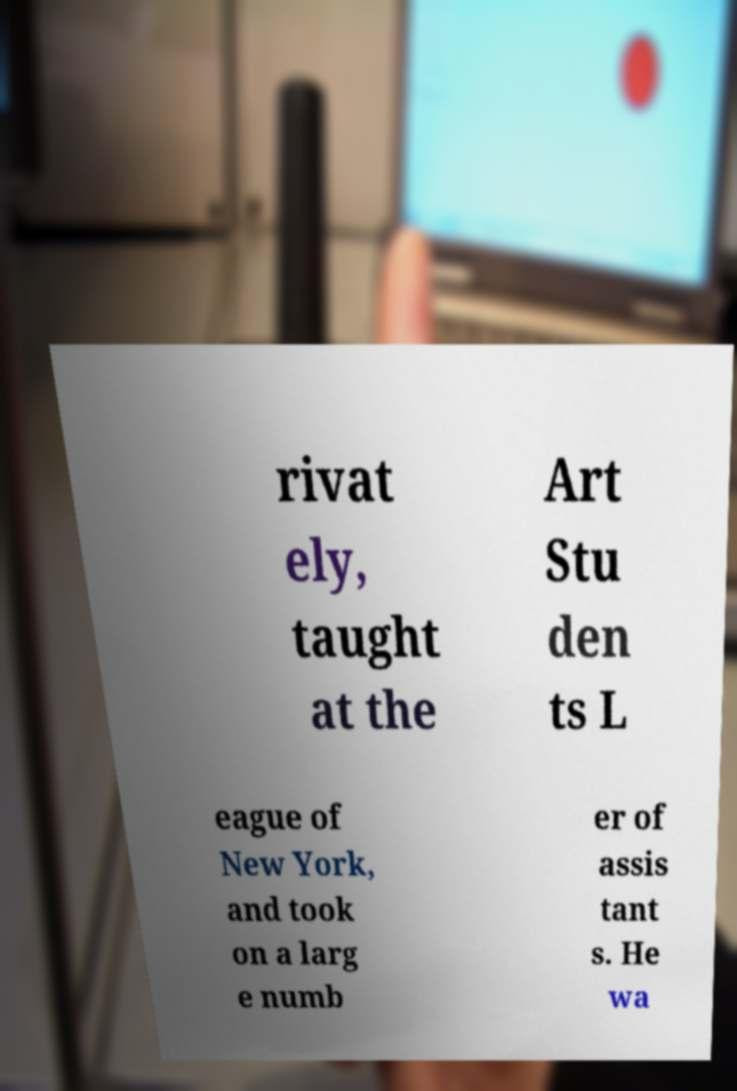What messages or text are displayed in this image? I need them in a readable, typed format. rivat ely, taught at the Art Stu den ts L eague of New York, and took on a larg e numb er of assis tant s. He wa 